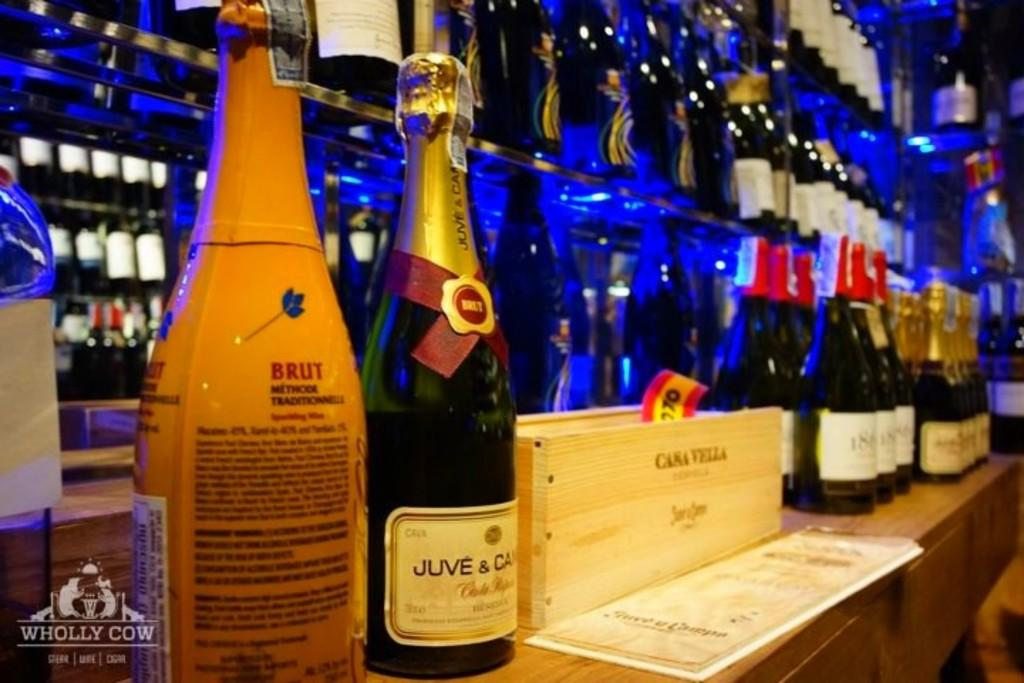<image>
Give a short and clear explanation of the subsequent image. A bar with several bottles of wine and champagne on shelves including one called Brut. 